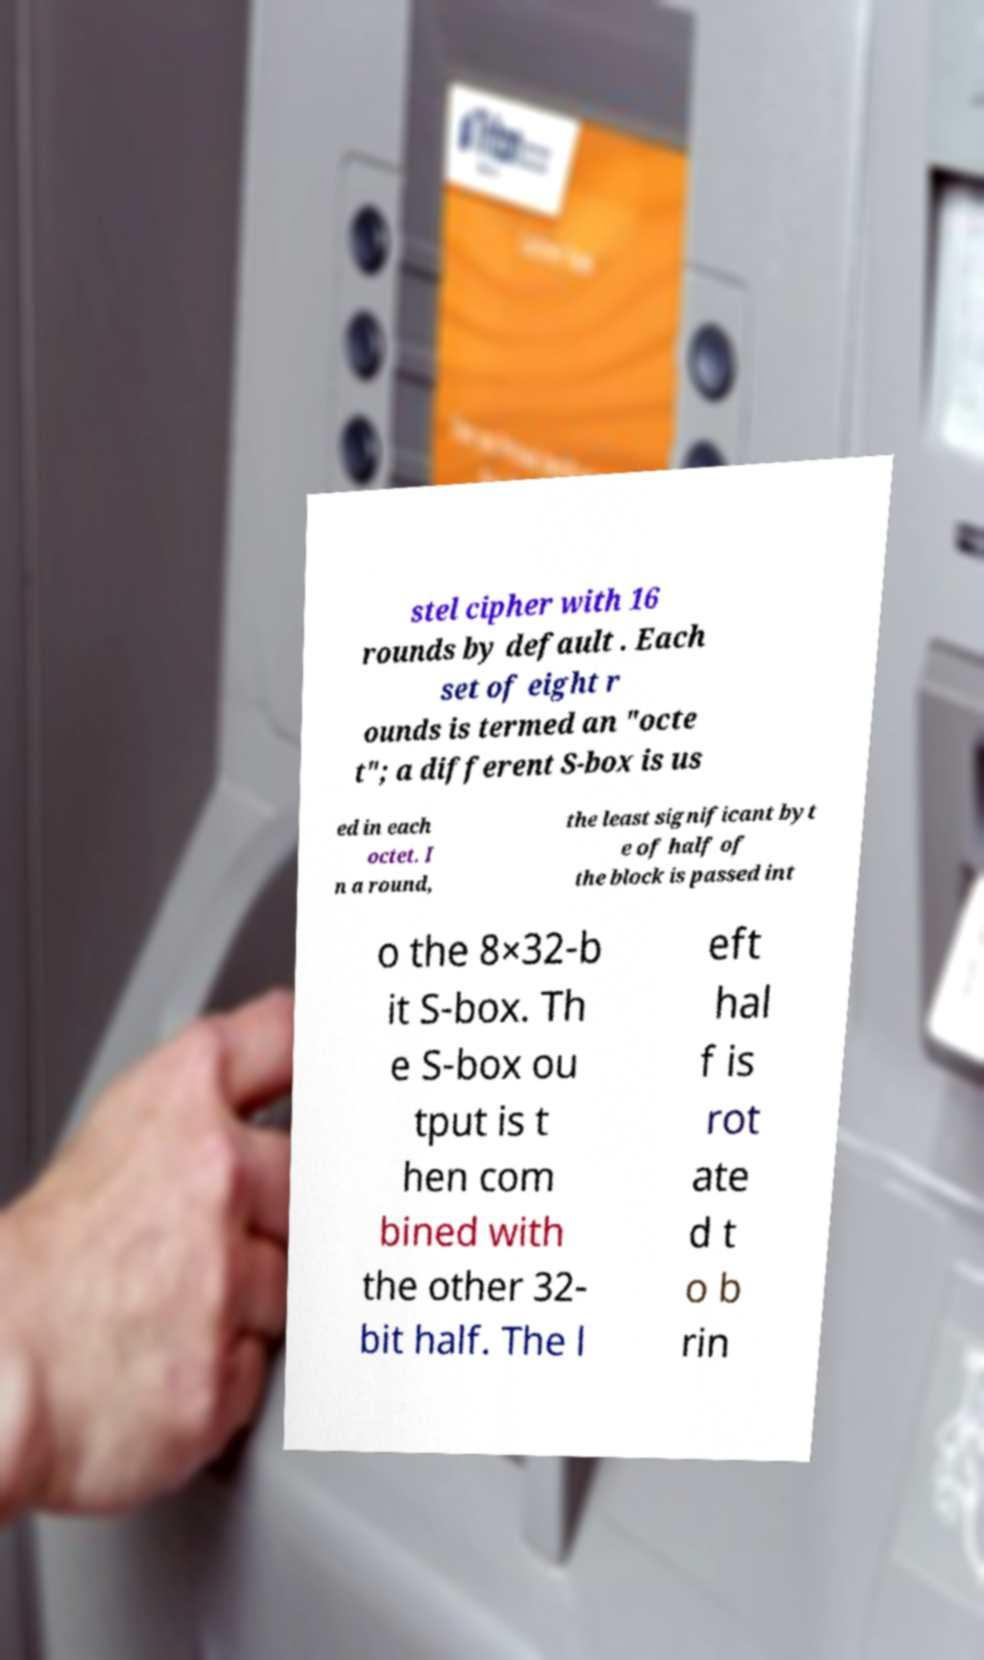Can you accurately transcribe the text from the provided image for me? stel cipher with 16 rounds by default . Each set of eight r ounds is termed an "octe t"; a different S-box is us ed in each octet. I n a round, the least significant byt e of half of the block is passed int o the 8×32-b it S-box. Th e S-box ou tput is t hen com bined with the other 32- bit half. The l eft hal f is rot ate d t o b rin 